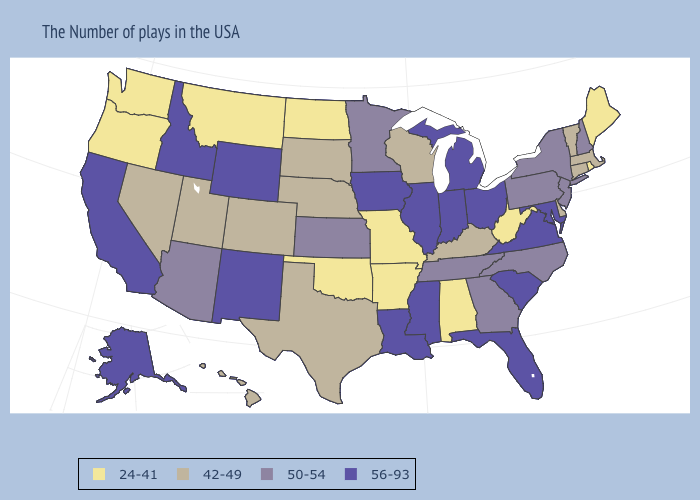What is the lowest value in the West?
Be succinct. 24-41. What is the value of Wisconsin?
Keep it brief. 42-49. What is the lowest value in the USA?
Keep it brief. 24-41. Does Wisconsin have a lower value than North Dakota?
Write a very short answer. No. Does Minnesota have the highest value in the MidWest?
Quick response, please. No. What is the value of Washington?
Keep it brief. 24-41. What is the lowest value in states that border New Jersey?
Concise answer only. 42-49. Name the states that have a value in the range 42-49?
Be succinct. Massachusetts, Vermont, Connecticut, Delaware, Kentucky, Wisconsin, Nebraska, Texas, South Dakota, Colorado, Utah, Nevada, Hawaii. What is the lowest value in the USA?
Write a very short answer. 24-41. Name the states that have a value in the range 24-41?
Keep it brief. Maine, Rhode Island, West Virginia, Alabama, Missouri, Arkansas, Oklahoma, North Dakota, Montana, Washington, Oregon. Does the first symbol in the legend represent the smallest category?
Be succinct. Yes. What is the value of Alabama?
Concise answer only. 24-41. What is the highest value in the South ?
Write a very short answer. 56-93. Does Illinois have the highest value in the USA?
Quick response, please. Yes. 